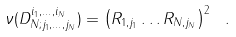<formula> <loc_0><loc_0><loc_500><loc_500>\nu ( D _ { N ; j _ { 1 } , \dots , j _ { N } } ^ { i _ { 1 } , \dots , i _ { N } } ) = \left ( R _ { 1 , j _ { 1 } } \dots R _ { N , j _ { N } } \right ) ^ { 2 } \ .</formula> 